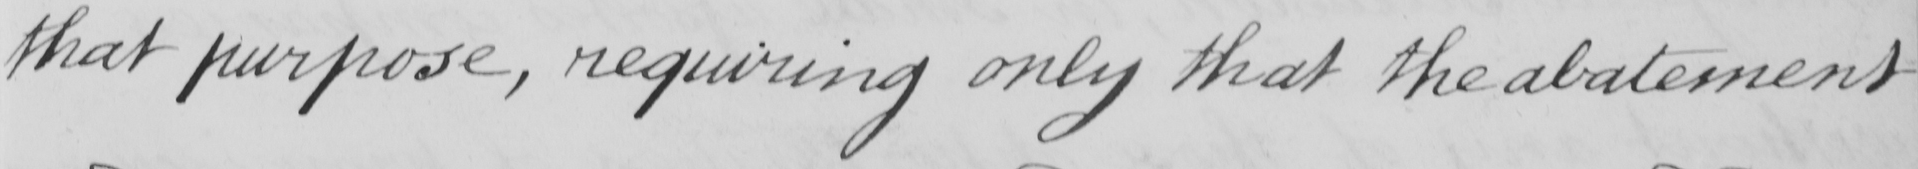Can you tell me what this handwritten text says? that purpose , requiring only that the abatement 